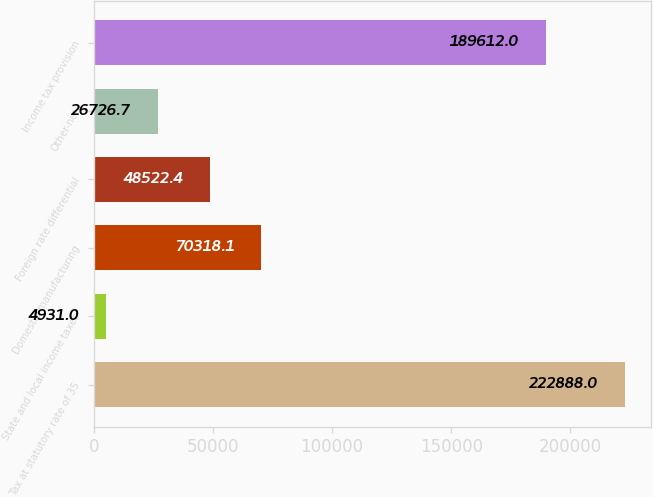Convert chart. <chart><loc_0><loc_0><loc_500><loc_500><bar_chart><fcel>Tax at statutory rate of 35<fcel>State and local income taxes<fcel>Domestic manufacturing<fcel>Foreign rate differential<fcel>Other-net<fcel>Income tax provision<nl><fcel>222888<fcel>4931<fcel>70318.1<fcel>48522.4<fcel>26726.7<fcel>189612<nl></chart> 